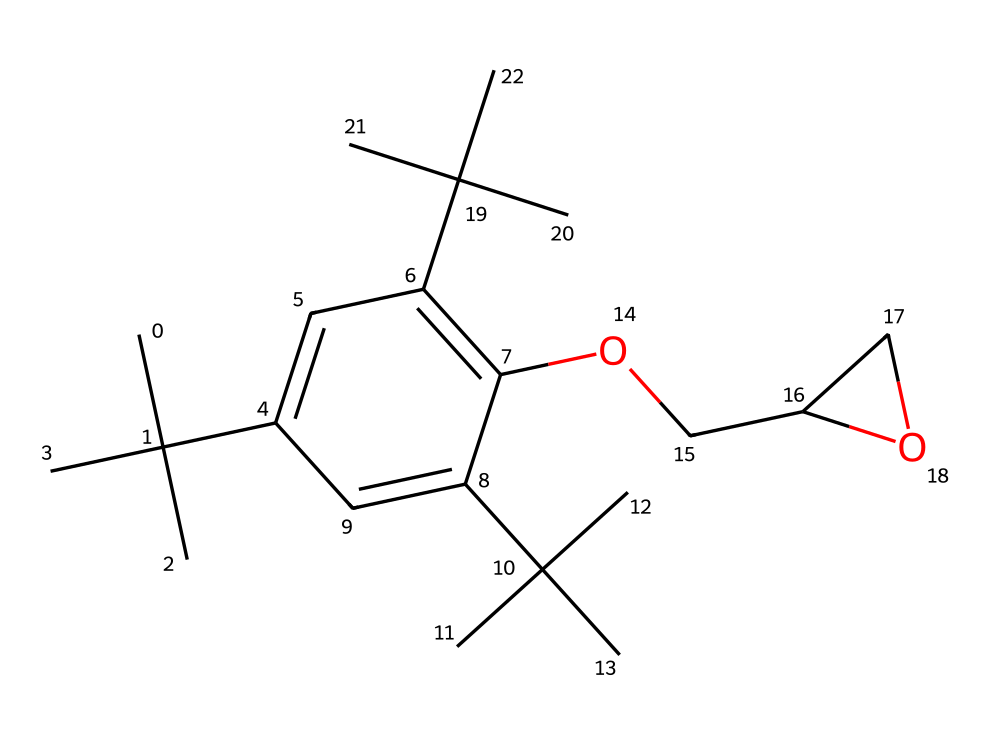What is the total number of carbon atoms in the structure? Count the carbon atoms depicted in the SMILES representation, noting each occurrence of "C" that represents carbon. There are 21 carbon atoms in the structure.
Answer: 21 How many oxygen atoms are present in the epoxy resin monomer? Review the SMILES representation for the "O" symbols, as these denote oxygen atoms. In total, there are 2 oxygen atoms in this structure.
Answer: 2 What functional group is indicated by the presence of "OCC" in the structure? The "OCC" suggests an ether functional group, as it consists of an oxygen atom connected to two carbon atoms. This points towards ether characteristics in the chemical.
Answer: ether Is this chemical likely to be a solid, liquid, or gas at room temperature? Given the complexities of the structure with multiple carbon chains and functional groups, it suggests higher molecular weight and density, pointing to this compound likely being a solid at room temperature.
Answer: solid What type of bond types are primarily present in this monomer? Examining the structure, the primary bond types are single bonds (between carbon and carbon, as well as carbon and oxygen) and some double bonds (indicated by "=" signs). This indicates a mix but predominantly single bonds.
Answer: single and double bonds What is the significance of the hydroxyl group in this resin? The presence of a hydroxyl group (-OH) in the structure (as indicated by "C(O") contributes to the resin's reactivity in curing processes, promoting cross-linking in polymer formation.
Answer: reactivity in curing processes How many branching points can be identified in the monomer? Analyze the structure for points where branches occur, particularly where carbon atoms attach to more than two others. There are multiple branched carbon groups, indicating a total of 6 branching points.
Answer: 6 